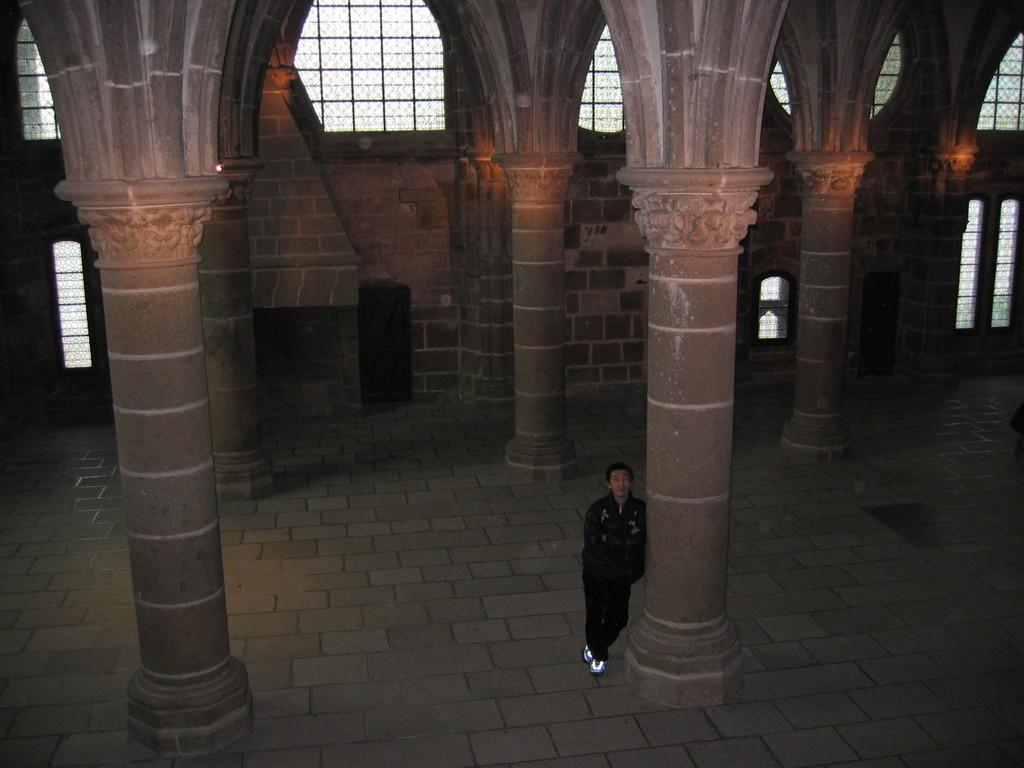Where was the image taken? The image was taken in a hall. What can be seen in the center of the image? There is a man standing in the center of the image. What architectural features are present in the image? There are pillars in the image. What can be seen in the background of the image? There are windows in the background of the image. How many lizards are crawling on the pillars in the image? There are no lizards present in the image; it only features a man standing in the center and pillars. What type of shade is provided by the windows in the image? The image does not show any shade provided by the windows, as it only depicts the windows in the background. 